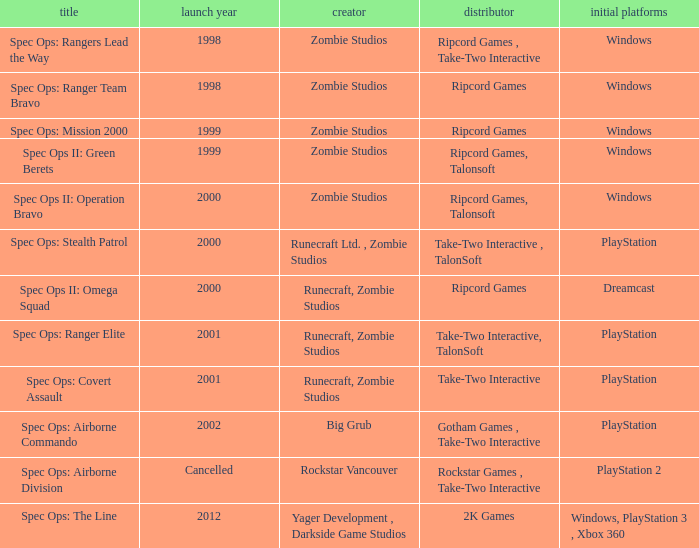Parse the full table. {'header': ['title', 'launch year', 'creator', 'distributor', 'initial platforms'], 'rows': [['Spec Ops: Rangers Lead the Way', '1998', 'Zombie Studios', 'Ripcord Games , Take-Two Interactive', 'Windows'], ['Spec Ops: Ranger Team Bravo', '1998', 'Zombie Studios', 'Ripcord Games', 'Windows'], ['Spec Ops: Mission 2000', '1999', 'Zombie Studios', 'Ripcord Games', 'Windows'], ['Spec Ops II: Green Berets', '1999', 'Zombie Studios', 'Ripcord Games, Talonsoft', 'Windows'], ['Spec Ops II: Operation Bravo', '2000', 'Zombie Studios', 'Ripcord Games, Talonsoft', 'Windows'], ['Spec Ops: Stealth Patrol', '2000', 'Runecraft Ltd. , Zombie Studios', 'Take-Two Interactive , TalonSoft', 'PlayStation'], ['Spec Ops II: Omega Squad', '2000', 'Runecraft, Zombie Studios', 'Ripcord Games', 'Dreamcast'], ['Spec Ops: Ranger Elite', '2001', 'Runecraft, Zombie Studios', 'Take-Two Interactive, TalonSoft', 'PlayStation'], ['Spec Ops: Covert Assault', '2001', 'Runecraft, Zombie Studios', 'Take-Two Interactive', 'PlayStation'], ['Spec Ops: Airborne Commando', '2002', 'Big Grub', 'Gotham Games , Take-Two Interactive', 'PlayStation'], ['Spec Ops: Airborne Division', 'Cancelled', 'Rockstar Vancouver', 'Rockstar Games , Take-Two Interactive', 'PlayStation 2'], ['Spec Ops: The Line', '2012', 'Yager Development , Darkside Game Studios', '2K Games', 'Windows, PlayStation 3 , Xbox 360']]} Which publisher has release year of 2000 and an original dreamcast platform? Ripcord Games. 